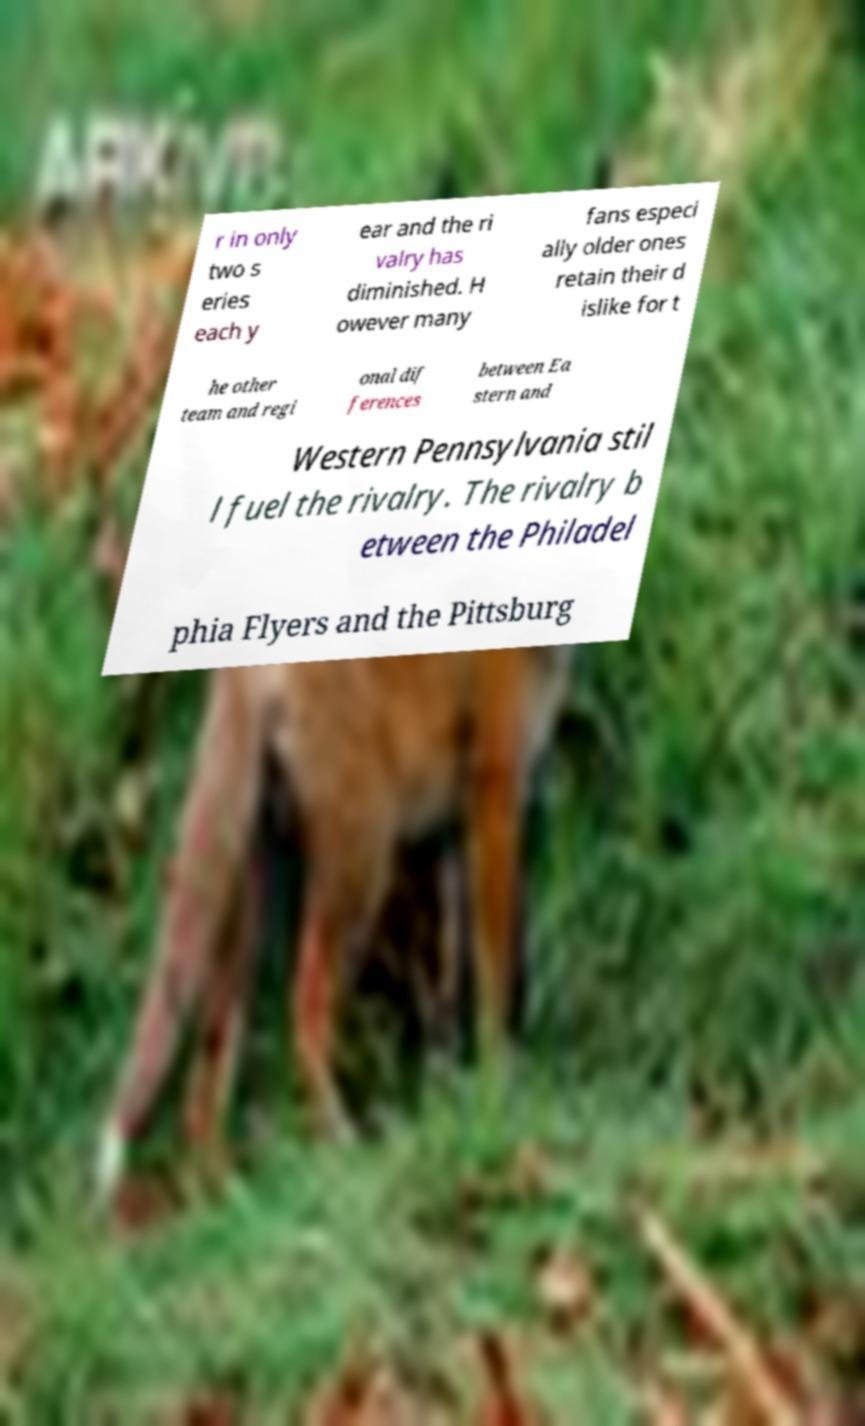Please read and relay the text visible in this image. What does it say? r in only two s eries each y ear and the ri valry has diminished. H owever many fans especi ally older ones retain their d islike for t he other team and regi onal dif ferences between Ea stern and Western Pennsylvania stil l fuel the rivalry. The rivalry b etween the Philadel phia Flyers and the Pittsburg 